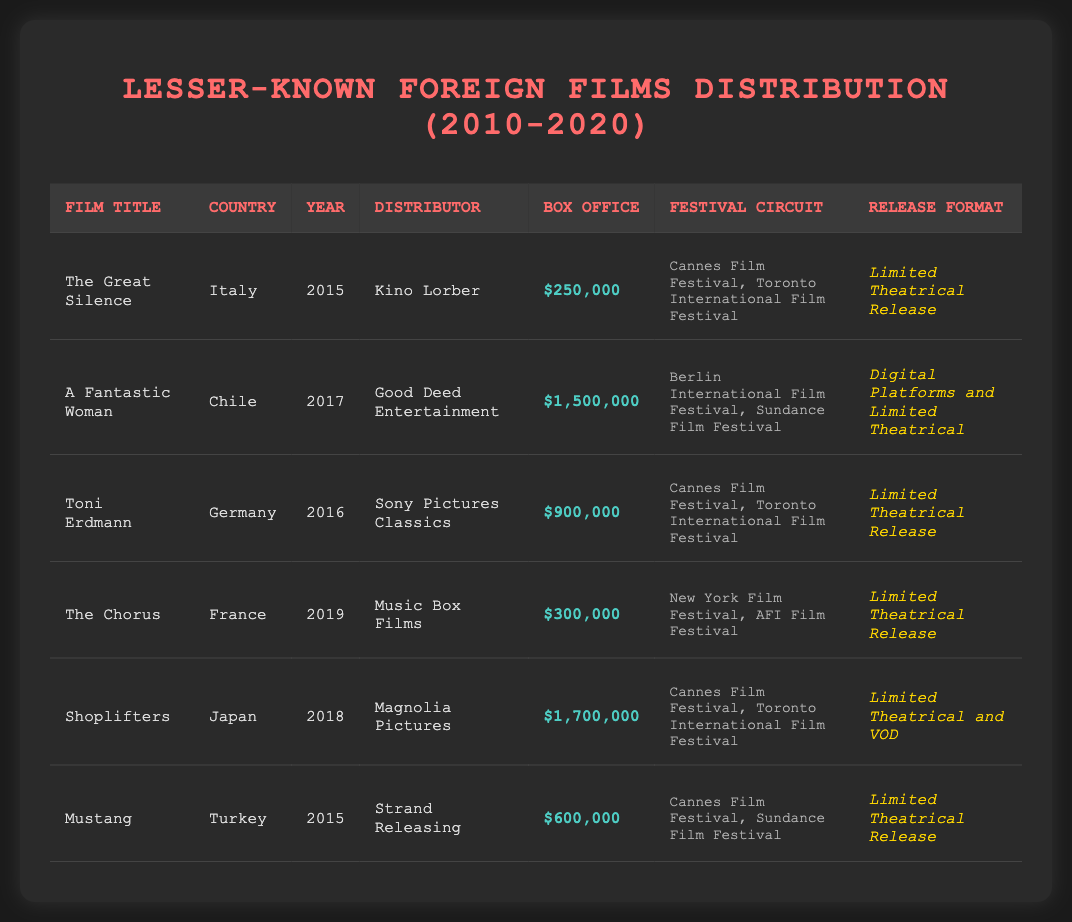What is the title of the film distributed by Kino Lorber? The table lists the distributor for each film, and it shows that Kino Lorber distributed "The Great Silence."
Answer: The Great Silence Which country produced "A Fantastic Woman"? The table indicates that "A Fantastic Woman" is from Chile, as mentioned in the "Country" column for that film.
Answer: Chile How much did "Shoplifters" earn at the box office? The box office earnings for "Shoplifters" is listed as $1,700,000 in the corresponding column of the table.
Answer: $1,700,000 What is the total box office earnings of "The Great Silence," "The Chorus," and "Mustang"? To find the total box office earnings, we need to add the values: $250,000 (The Great Silence) + $300,000 (The Chorus) + $600,000 (Mustang) = $1,150,000.
Answer: $1,150,000 Did any film have a box office earning greater than $1.5 million? Upon checking the box office earnings of all films, the highest is $1,700,000 for "Shoplifters," which exceeds $1.5 million.
Answer: Yes How many films used a Limited Theatrical Release format? By examining the "Release Format" column, it is found that four films—"The Great Silence," "Toni Erdmann," "The Chorus," and "Mustang"—used the Limited Theatrical Release format.
Answer: 4 Which film had the highest box office earnings and what was that amount? A review of the box office column shows that "Shoplifters" has the highest box office earnings, amounting to $1,700,000.
Answer: Shoplifters; $1,700,000 What is the median box office earning of the films listed? First, we list the box office earnings: $250,000, $1,500,000, $900,000, $300,000, $1,700,000, $600,000. Sorting these gives us: $250,000, $300,000, $600,000, $900,000, $1,500,000, $1,700,000. With 6 films, the median is the average of the 3rd and 4th values: ($600,000 + $900,000) / 2 = $750,000.
Answer: $750,000 Which festival appeared most frequently in the festival circuit for these films? By reviewing the "Festival Circuit" for each film, "Cannes Film Festival" appears for four films—“The Great Silence,” “Toni Erdmann,” “Shoplifters,” and “Mustang”—making it the most frequent.
Answer: Cannes Film Festival 